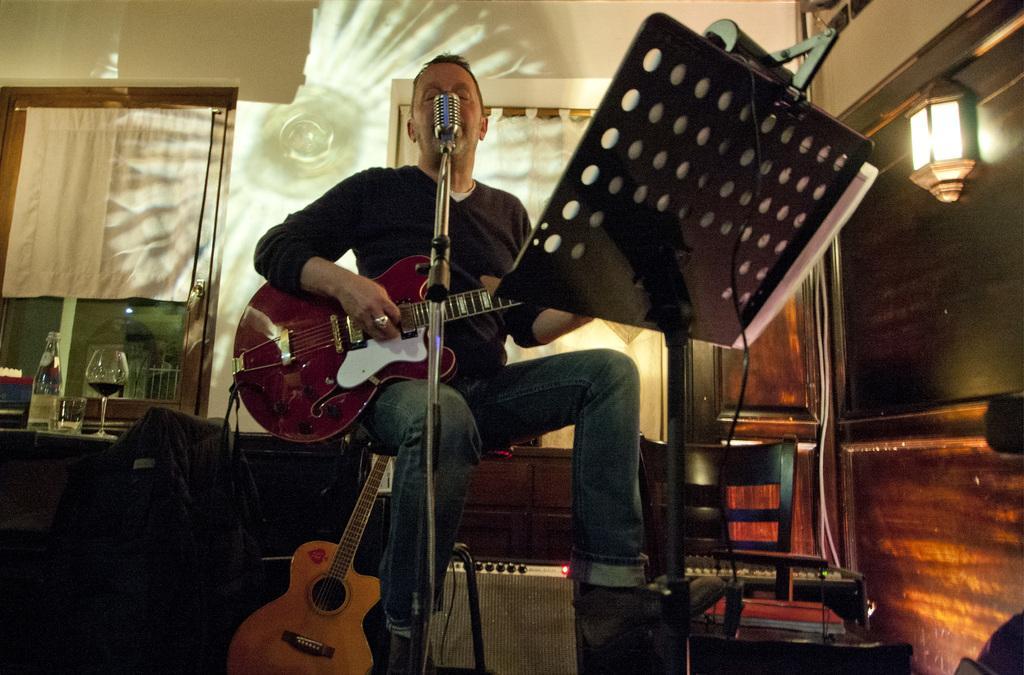Describe this image in one or two sentences. On the background we can see wall, windows and curtains. On the table we can see wine glass, bottle and empty glass. We can see a man sitting on a stool in front of a mike and playing guitar. This is a table and we can see papers on it. Here we can see guitar on the floor. 